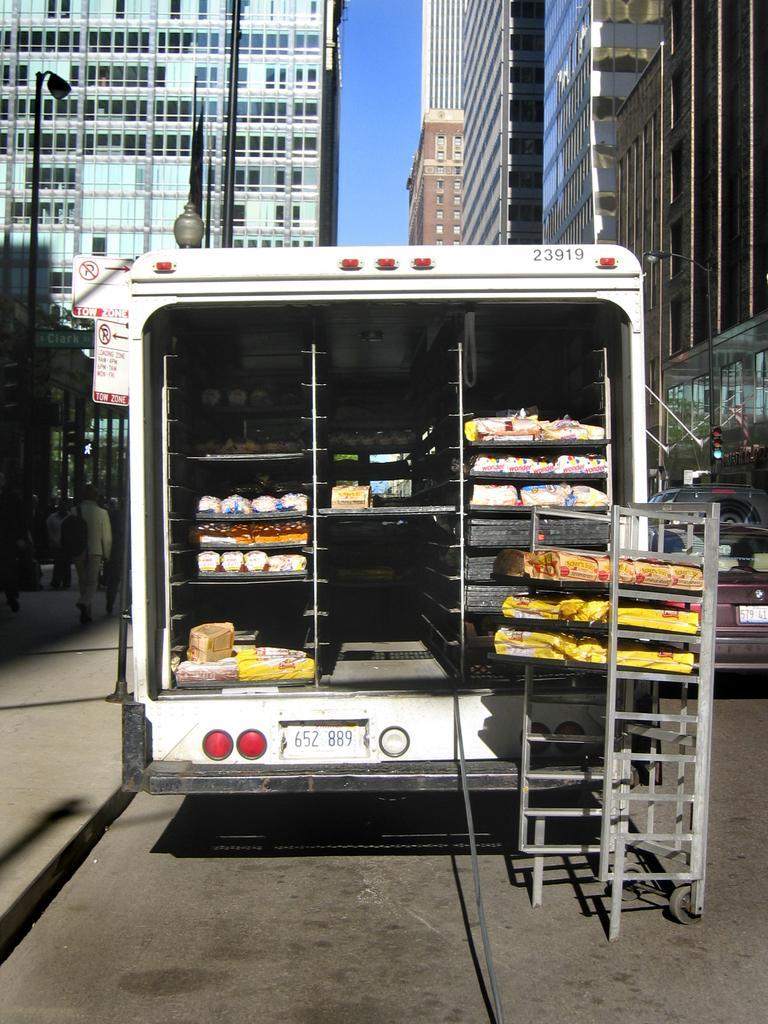Can you describe this image briefly? In this picture I can observe a vehicle. There are some racks in this vehicle. I can observe some poles. In the background there are buildings and a sky. 